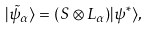Convert formula to latex. <formula><loc_0><loc_0><loc_500><loc_500>| { \tilde { \psi } } _ { \alpha } \rangle = ( S \otimes L _ { \alpha } ) | \psi ^ { \ast } \rangle ,</formula> 